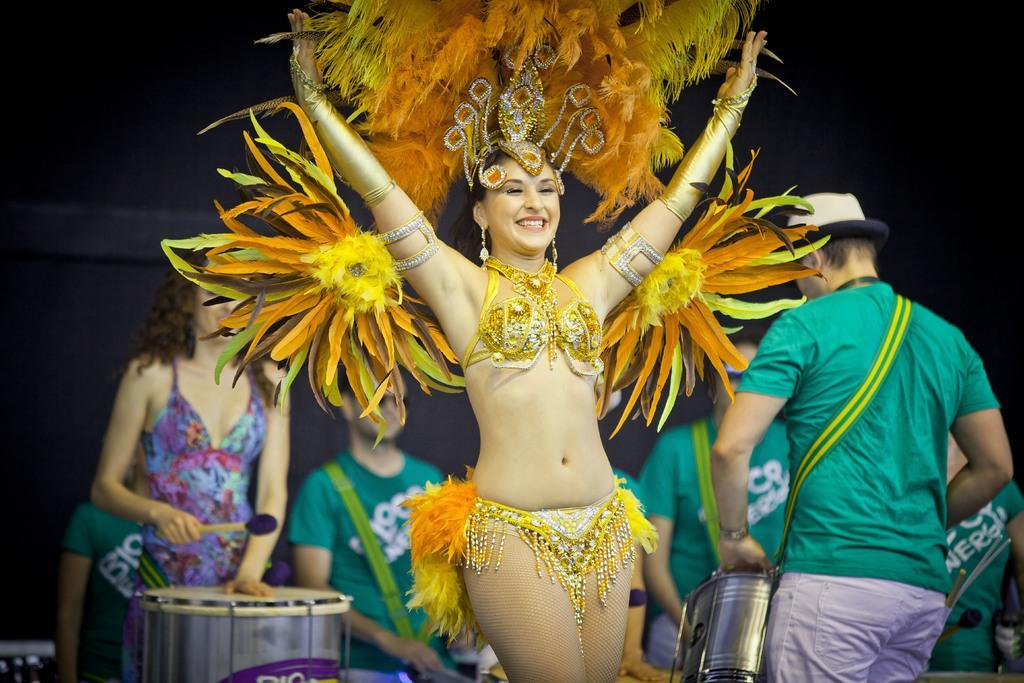Please provide a concise description of this image. There is a girl in the center of the image she is wearing a costume and there are people behind her, it seems like they are playing drums and the background area is black. 